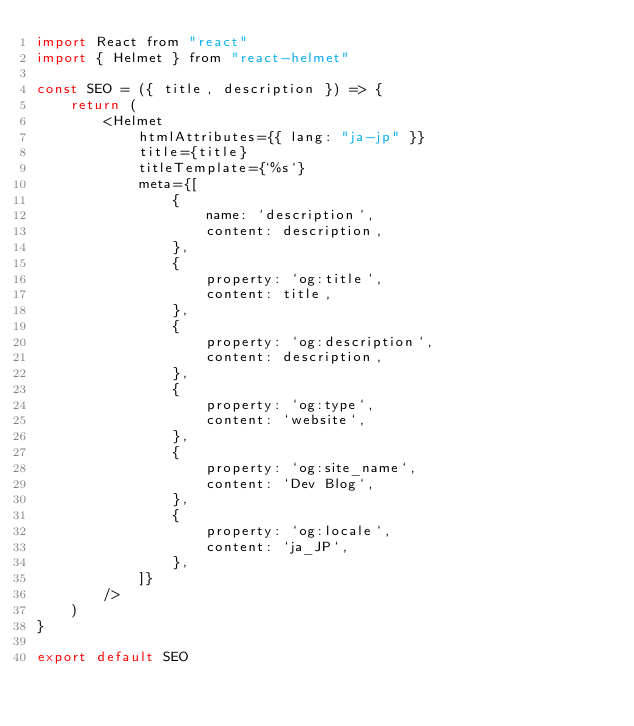<code> <loc_0><loc_0><loc_500><loc_500><_JavaScript_>import React from "react"
import { Helmet } from "react-helmet"

const SEO = ({ title, description }) => {
    return (
        <Helmet
            htmlAttributes={{ lang: "ja-jp" }}
            title={title}
            titleTemplate={`%s`}
            meta={[
                {
                    name: `description`,
                    content: description,
                },
                {
                    property: `og:title`,
                    content: title,
                },
                {
                    property: `og:description`,
                    content: description,
                },
                {
                    property: `og:type`,
                    content: `website`,
                },
                {
                    property: `og:site_name`,
                    content: `Dev Blog`,
                },
                {
                    property: `og:locale`,
                    content: `ja_JP`,
                },
            ]}
        />
    )
}

export default SEO</code> 